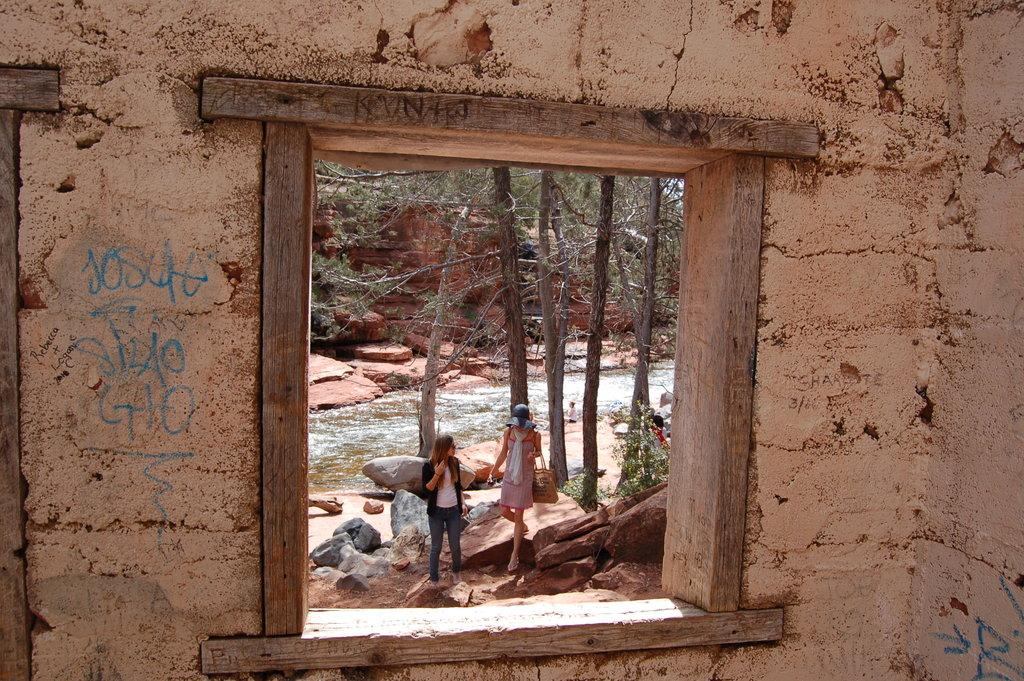What type of structure can be seen in the image? There is a wall in the image. What feature is present in the wall? There is a window in the image. What can be seen through the window? People, trees, a canal, and rocks are visible through the window. What type of throat condition can be seen in the image? There is no throat condition present in the image. Is there a spy visible in the image? There is no indication of a spy in the image. 